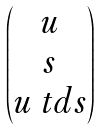<formula> <loc_0><loc_0><loc_500><loc_500>\begin{pmatrix} u \\ s \\ u \ t d s \end{pmatrix}</formula> 